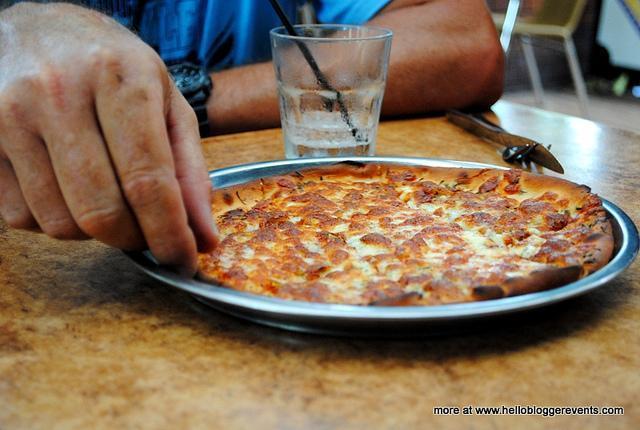Is the caption "The person is touching the pizza." a true representation of the image?
Answer yes or no. Yes. 